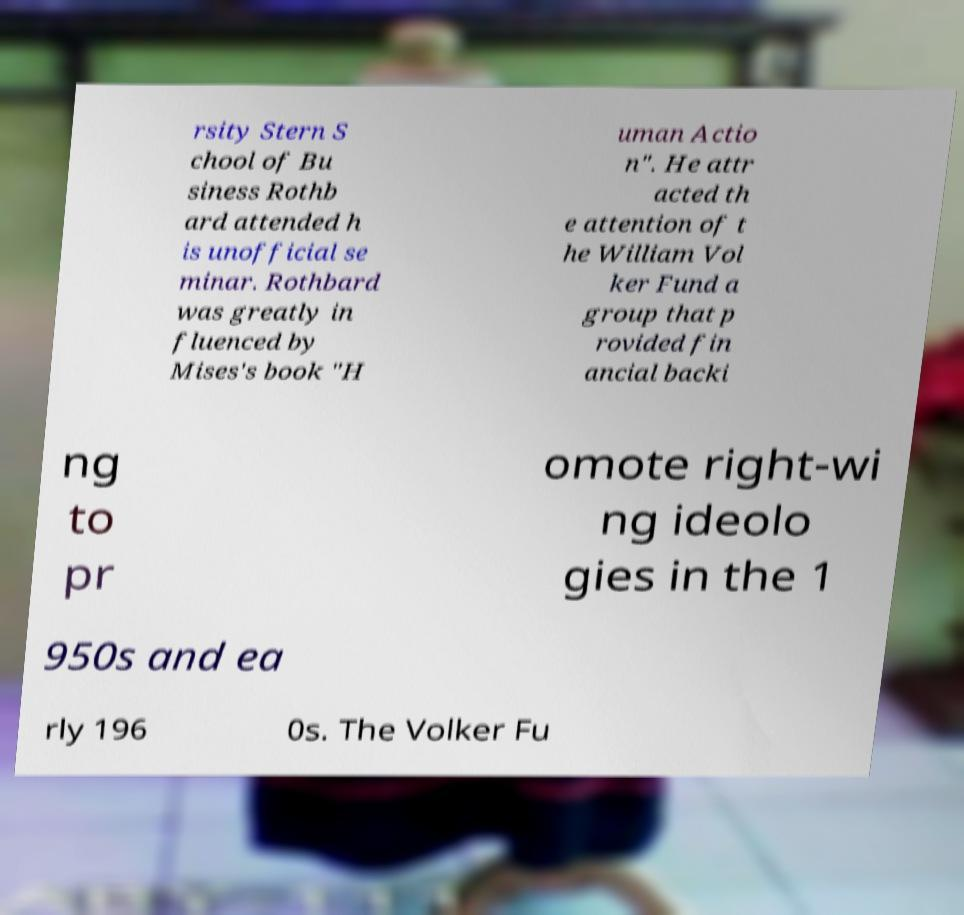Could you extract and type out the text from this image? rsity Stern S chool of Bu siness Rothb ard attended h is unofficial se minar. Rothbard was greatly in fluenced by Mises's book "H uman Actio n". He attr acted th e attention of t he William Vol ker Fund a group that p rovided fin ancial backi ng to pr omote right-wi ng ideolo gies in the 1 950s and ea rly 196 0s. The Volker Fu 